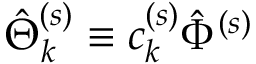Convert formula to latex. <formula><loc_0><loc_0><loc_500><loc_500>\hat { \Theta } _ { k } ^ { ( s ) } \equiv c _ { k } ^ { ( s ) } \hat { \Phi } ^ { ( s ) }</formula> 